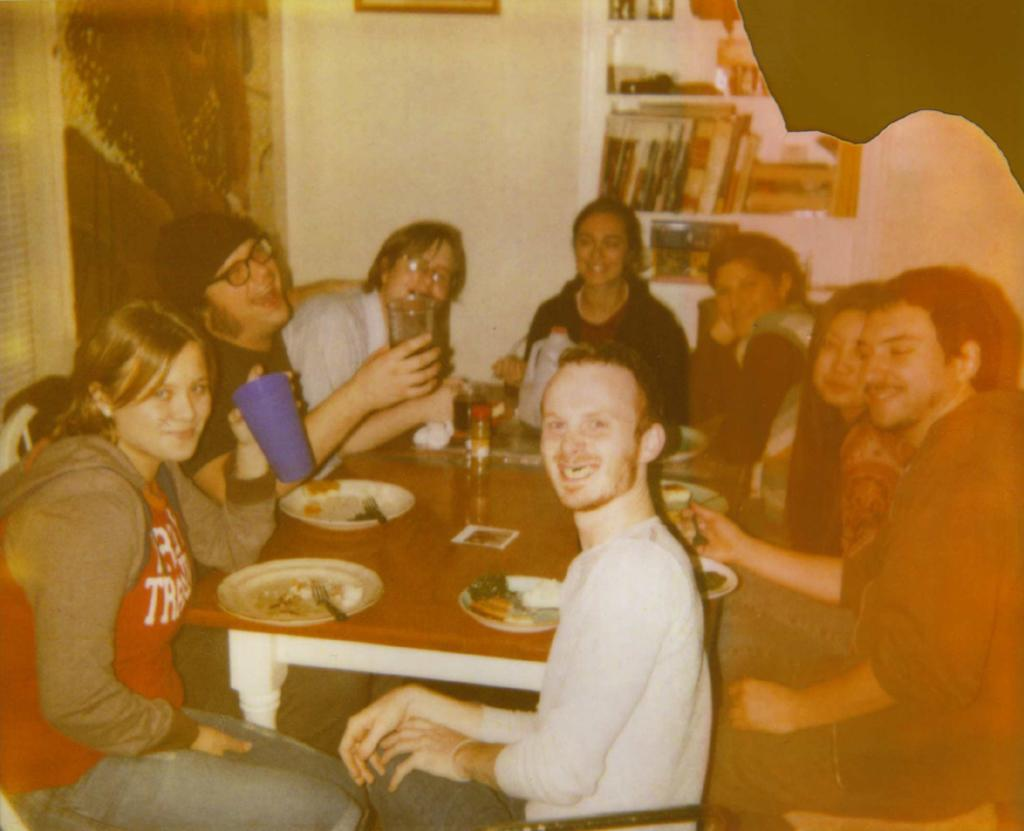How many people are in the image? There is a group of people in the image. What are the people doing in the image? The people are sitting on chairs. What is on the table in the image? There is a plate, a spoon, a tissue, and a glass on the table. What is in the background of the image? There is a cupboard and books in the background. What type of love is being expressed in the image? There is no indication of love being expressed in the image; it simply shows a group of people sitting on chairs. What color is the chalk used to write on the books in the background? There is no chalk or writing on the books in the background; they are simply visible as part of the background. 